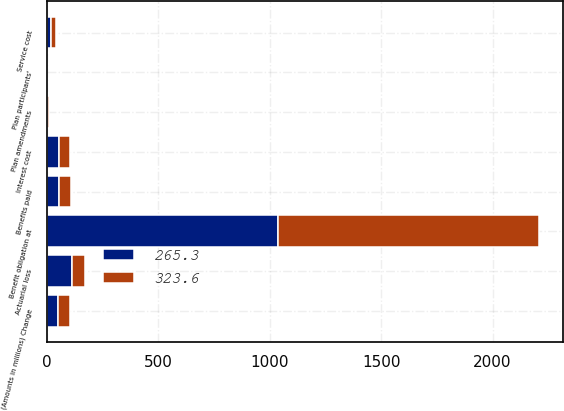Convert chart. <chart><loc_0><loc_0><loc_500><loc_500><stacked_bar_chart><ecel><fcel>(Amounts in millions) Change<fcel>Benefit obligation at<fcel>Service cost<fcel>Interest cost<fcel>Plan participants'<fcel>Benefits paid<fcel>Plan amendments<fcel>Actuarial loss<nl><fcel>323.6<fcel>52.75<fcel>1169.7<fcel>21.1<fcel>52<fcel>1.3<fcel>55.8<fcel>10.2<fcel>57.9<nl><fcel>265.3<fcel>52.75<fcel>1037.4<fcel>19.1<fcel>53.9<fcel>1.4<fcel>53.5<fcel>0.9<fcel>112.3<nl></chart> 